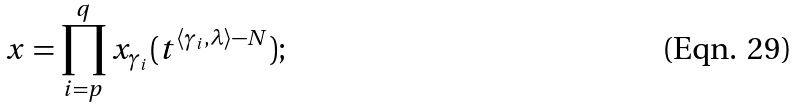<formula> <loc_0><loc_0><loc_500><loc_500>x = \prod _ { i = p } ^ { q } x _ { \gamma _ { i } } ( t ^ { \langle \gamma _ { i } , \lambda \rangle - N } ) ;</formula> 